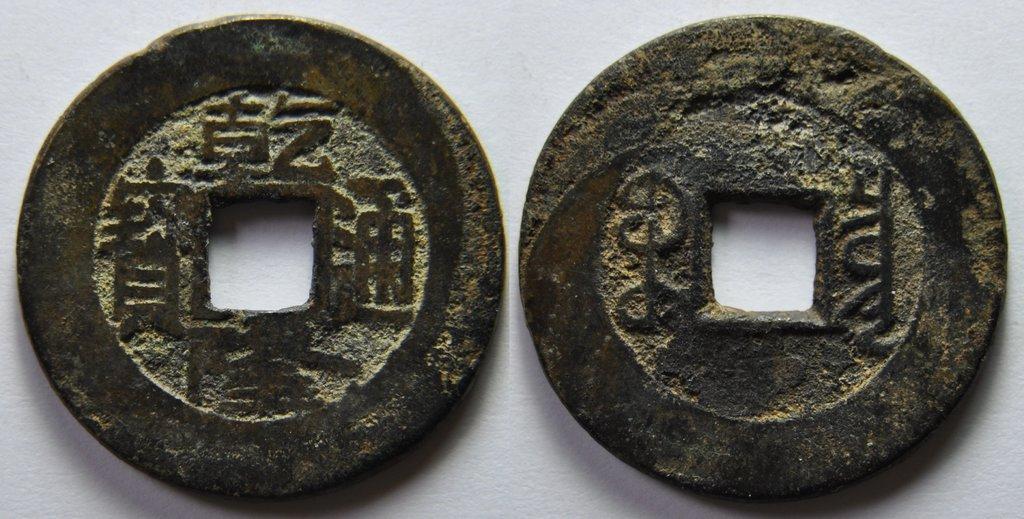Please provide a concise description of this image. In this picture we can see two coins on the surface. 